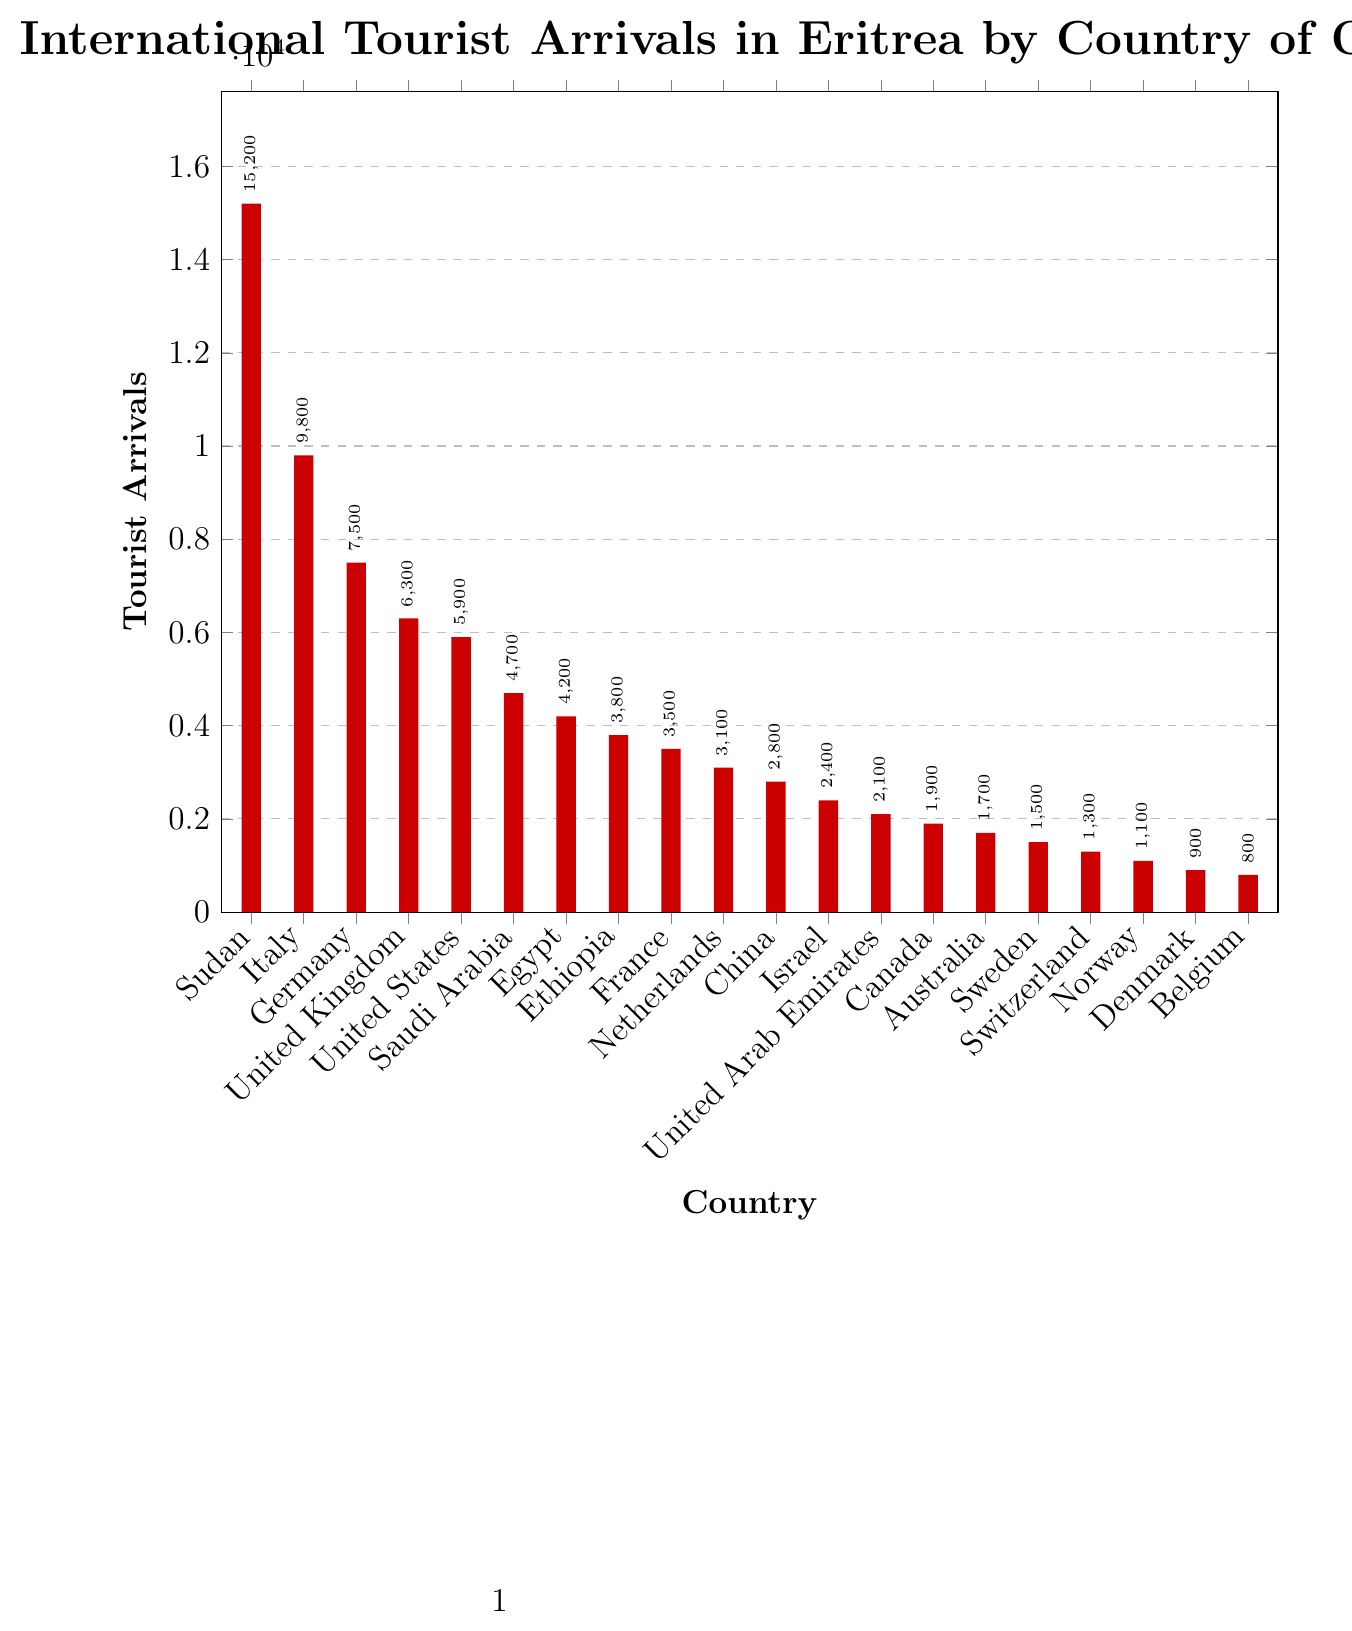What country contributes the highest number of international tourist arrivals in Eritrea? The highest bar represents the country with the most tourist arrivals. The bar corresponding to Sudan is the tallest.
Answer: Sudan Which two countries contribute more than 7,000 tourists each to Eritrea? Look at the bars that exceed the 7,000 mark. The bars for Sudan, Italy, and Germany exceed this value.
Answer: Sudan, Italy, Germany Compare the tourist arrivals from Saudi Arabia and Egypt. Which country sends more tourists to Eritrea? Find the bars corresponding to Saudi Arabia and Egypt. The bar for Saudi Arabia is higher than the bar for Egypt.
Answer: Saudi Arabia What is the combined total of tourist arrivals from the United States and Canada? Add the values for the United States (5900) and Canada (1900): 5900 + 1900 = 7800
Answer: 7800 Which country has the lowest number of tourist arrivals, and what is that number? Find the shortest bar to identify the country with the lowest number of arrivals, which is Belgium, with 800 arrivals.
Answer: Belgium, 800 By how much do tourist arrivals from Italy exceed those from the United Kingdom? Subtract the arrivals from the United Kingdom (6300) from those of Italy (9800): 9800 - 6300 = 3500
Answer: 3500 What is the average number of tourist arrivals for the countries listed? Sum all the tourist arrivals and divide by the number of countries: (15200 + 9800 + 7500 + 6300 + 5900 + 4700 + 4200 + 3800 + 3500 + 3100 + 2800 + 2400 + 2100 + 1900 + 1700 + 1500 + 1300 + 1100 + 900 + 800) / 20 = 53000 / 20 = 5300
Answer: 5300 Which countries contribute exactly 2100 tourist arrivals? Identify the bar with a height representing 2100 arrivals, which is the United Arab Emirates.
Answer: United Arab Emirates Compare Sweden and Denmark in terms of tourist arrivals. Which country has fewer tourists visiting Eritrea? Find the bars corresponding to Sweden and Denmark. The bar for Denmark is shorter than the bar for Sweden.
Answer: Denmark Calculate the total number of tourist arrivals from European countries listed. Sum the tourist arrivals for Italy, Germany, United Kingdom, France, Netherlands, Switzerland, Norway, Denmark, Belgium, and Sweden: 9800 + 7500 + 6300 + 3500 + 3100 + 1300 + 1100 + 900 + 800 + 1500 = 35800
Answer: 35800 